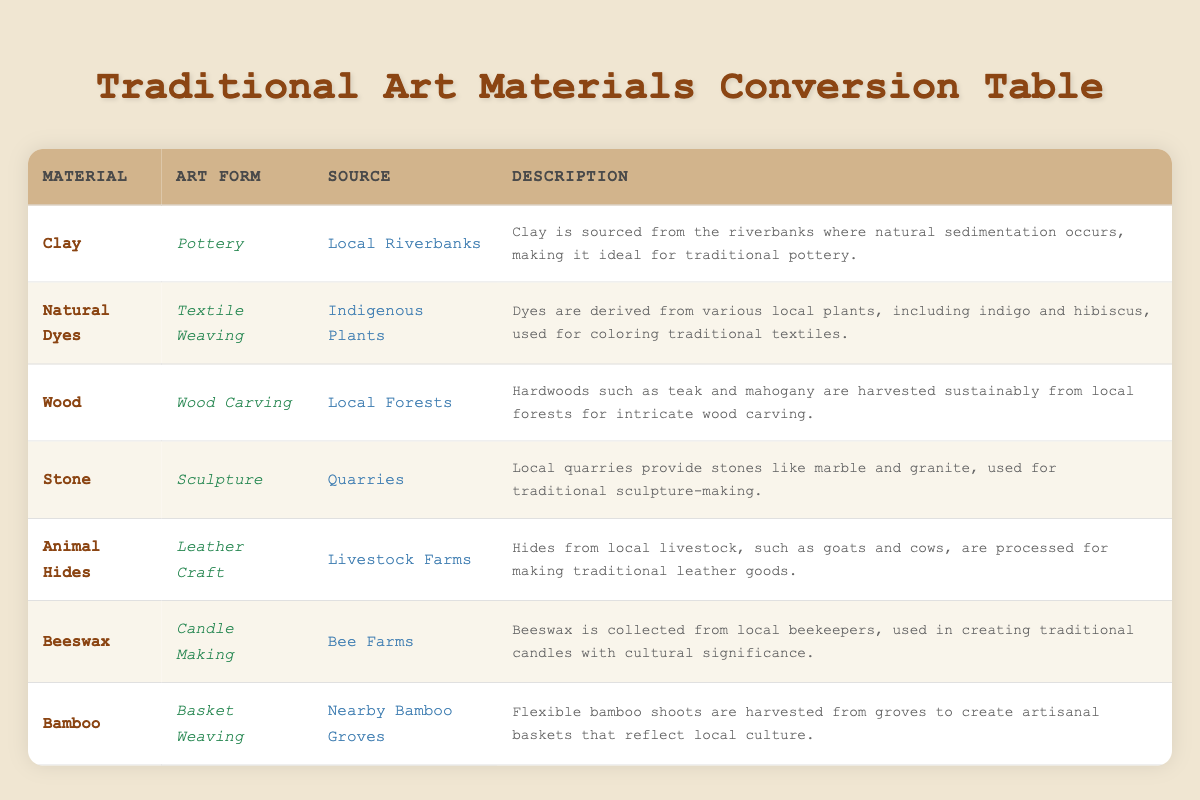What material is used for Pottery? According to the table, the material used for Pottery is Clay, as indicated in the row corresponding to Pottery.
Answer: Clay Which art form uses natural dyes? The table shows that natural dyes are used in the art form of Textile Weaving, as listed in the respective row.
Answer: Textile Weaving True or False: Beeswax is harvested from local forests. The table indicates that beeswax is collected from bee farms, not forests. Therefore, the statement is false.
Answer: False How many art forms are associated with materials sourced from local farms? Looking at the table, we see that Animal Hides (Leather Craft) and Beeswax (Candle Making) are both sourced from local farms. Thus, there are 2 art forms associated with local farms.
Answer: 2 What is the primary source of clay used in pottery? The table specifies that clay is sourced from Local Riverbanks, providing the precise information needed to answer the question.
Answer: Local Riverbanks Which traditional art material is derived from indigenous plants? The table reveals that Natural Dyes, used in Textile Weaving, are derived from Indigenous Plants. Thus, the answer is Natural Dyes.
Answer: Natural Dyes Is wood used in wood carving sourced sustainably? The description in the table for wood indicates that hardwoods such as teak and mahogany are harvested sustainably from local forests for wood carving, confirming the statement is true.
Answer: True What are the two materials used in sculpture-making and their sources? The table lists Stone as the primary material for Sculpture, sourced from Quarries, while we do not see another material specified. Since stone is the only material listed for sculpture-making and its source is explicitly stated, it appears there is only one.
Answer: Stone, Quarries If we count all unique sources listed in the table, what is the total number? The unique sources are: Local Riverbanks, Indigenous Plants, Local Forests, Quarries, Livestock Farms, Bee Farms, and Nearby Bamboo Groves. Counting these gives us 7 distinct sources total.
Answer: 7 